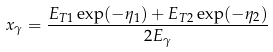Convert formula to latex. <formula><loc_0><loc_0><loc_500><loc_500>x _ { \gamma } = \frac { E _ { T 1 } \exp ( - \eta _ { 1 } ) + E _ { T 2 } \exp ( - \eta _ { 2 } ) } { 2 E _ { \gamma } }</formula> 